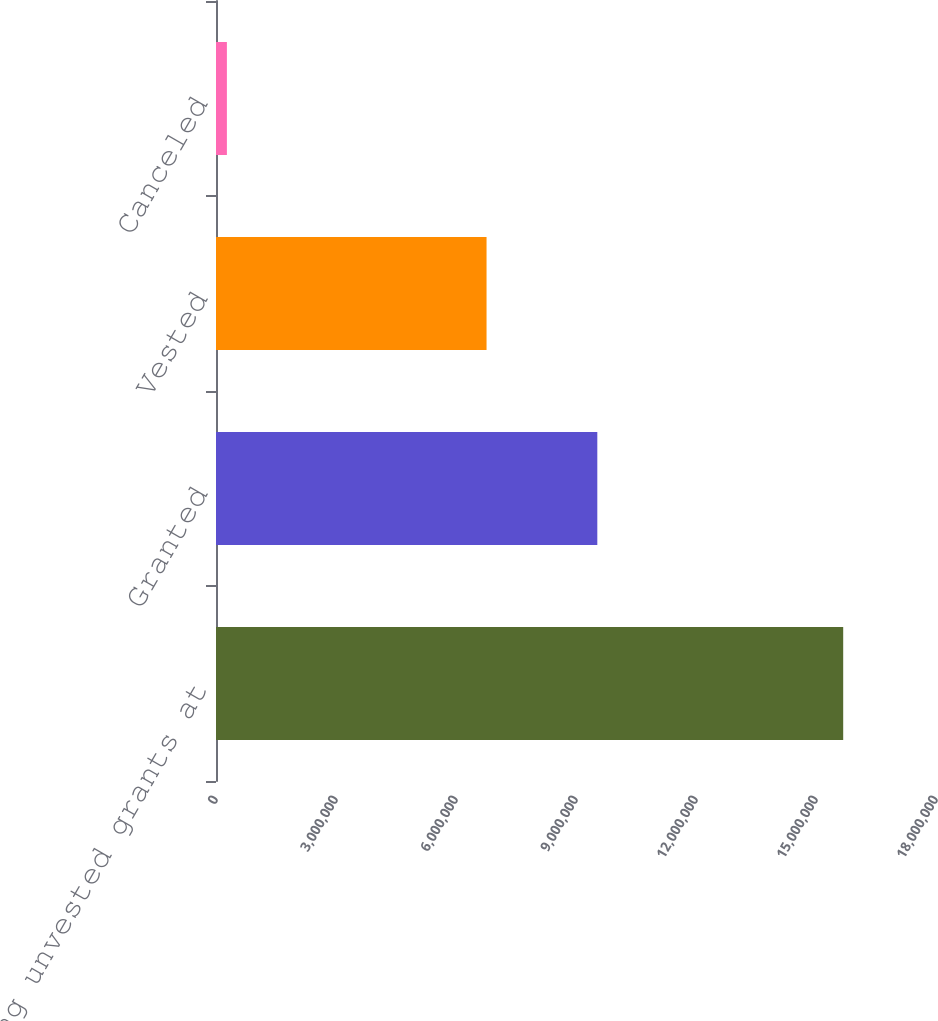Convert chart to OTSL. <chart><loc_0><loc_0><loc_500><loc_500><bar_chart><fcel>Outstanding unvested grants at<fcel>Granted<fcel>Vested<fcel>Canceled<nl><fcel>1.56799e+07<fcel>9.53275e+06<fcel>6.76375e+06<fcel>272554<nl></chart> 